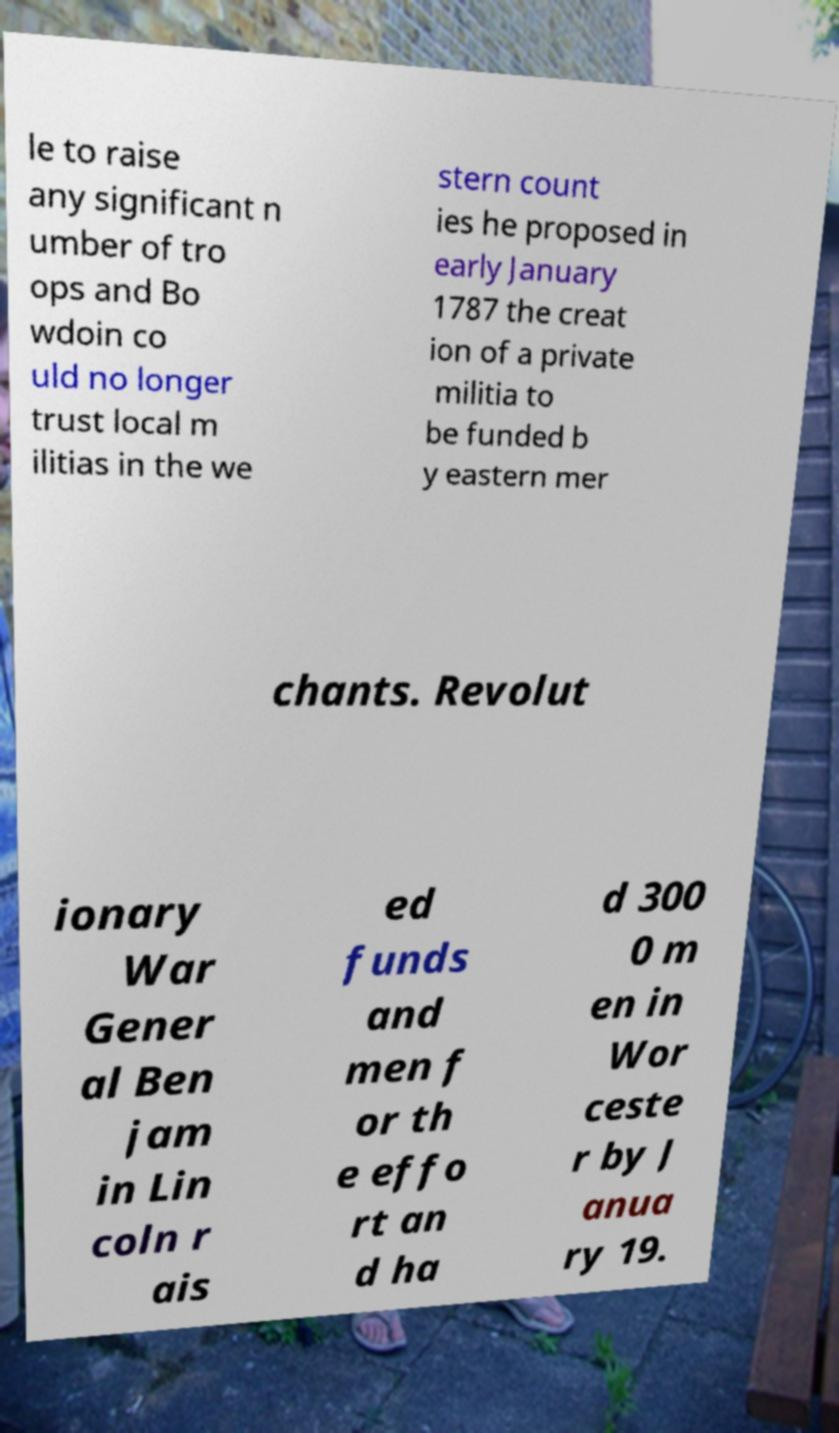Could you extract and type out the text from this image? le to raise any significant n umber of tro ops and Bo wdoin co uld no longer trust local m ilitias in the we stern count ies he proposed in early January 1787 the creat ion of a private militia to be funded b y eastern mer chants. Revolut ionary War Gener al Ben jam in Lin coln r ais ed funds and men f or th e effo rt an d ha d 300 0 m en in Wor ceste r by J anua ry 19. 